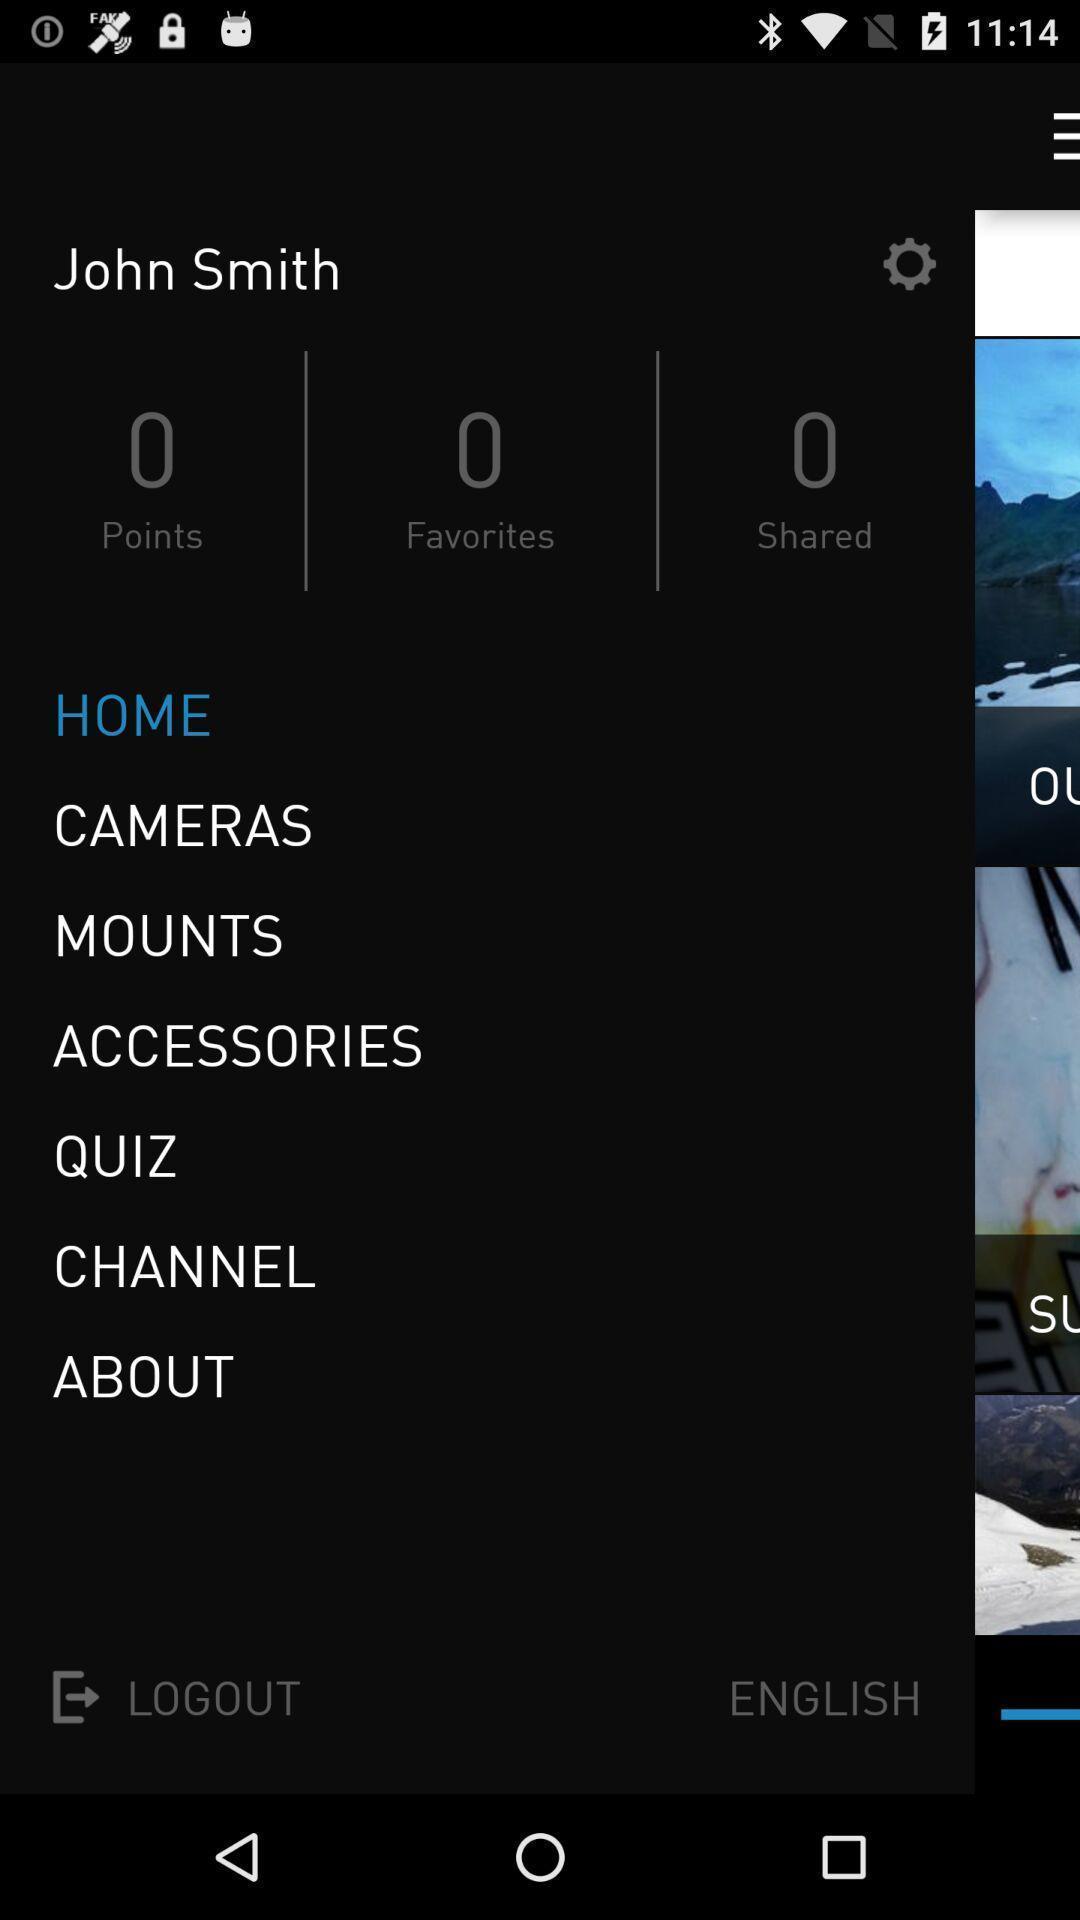Tell me what you see in this picture. Page showing side menu with options. 